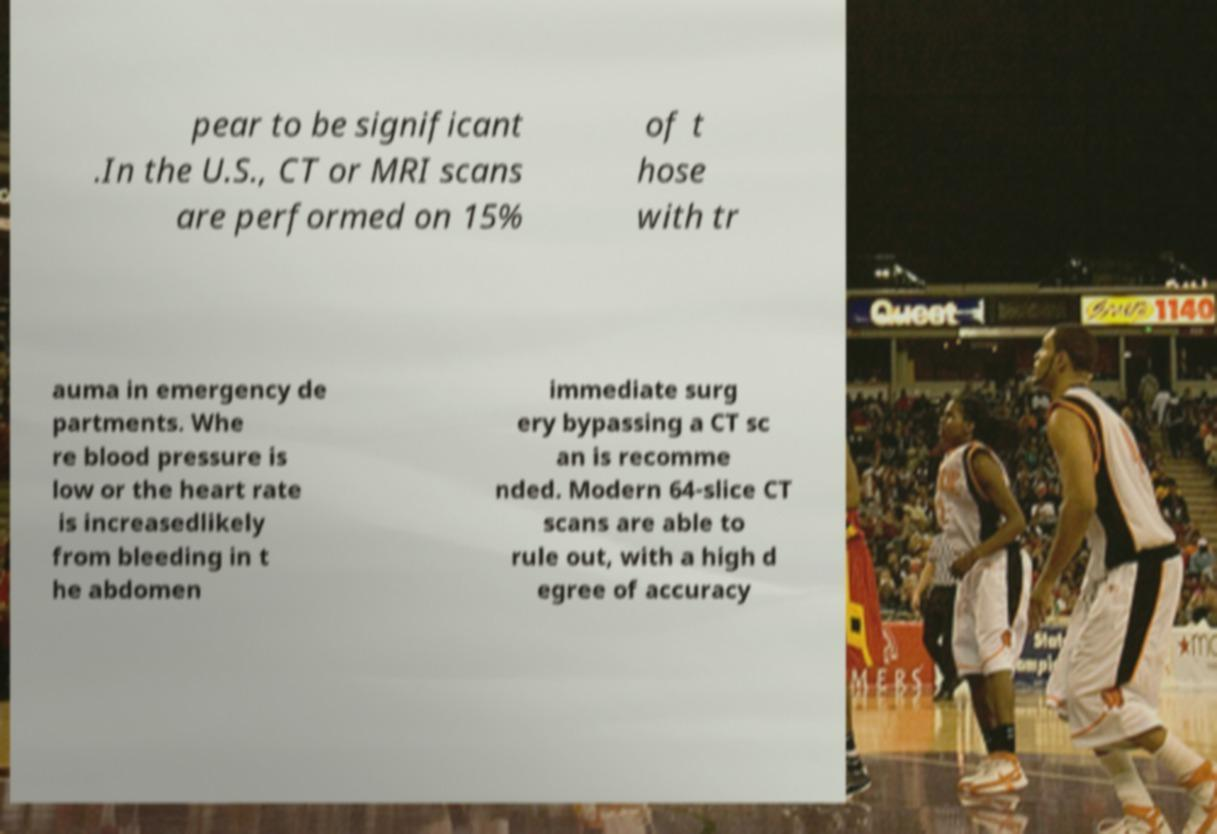Could you extract and type out the text from this image? pear to be significant .In the U.S., CT or MRI scans are performed on 15% of t hose with tr auma in emergency de partments. Whe re blood pressure is low or the heart rate is increasedlikely from bleeding in t he abdomen immediate surg ery bypassing a CT sc an is recomme nded. Modern 64-slice CT scans are able to rule out, with a high d egree of accuracy 